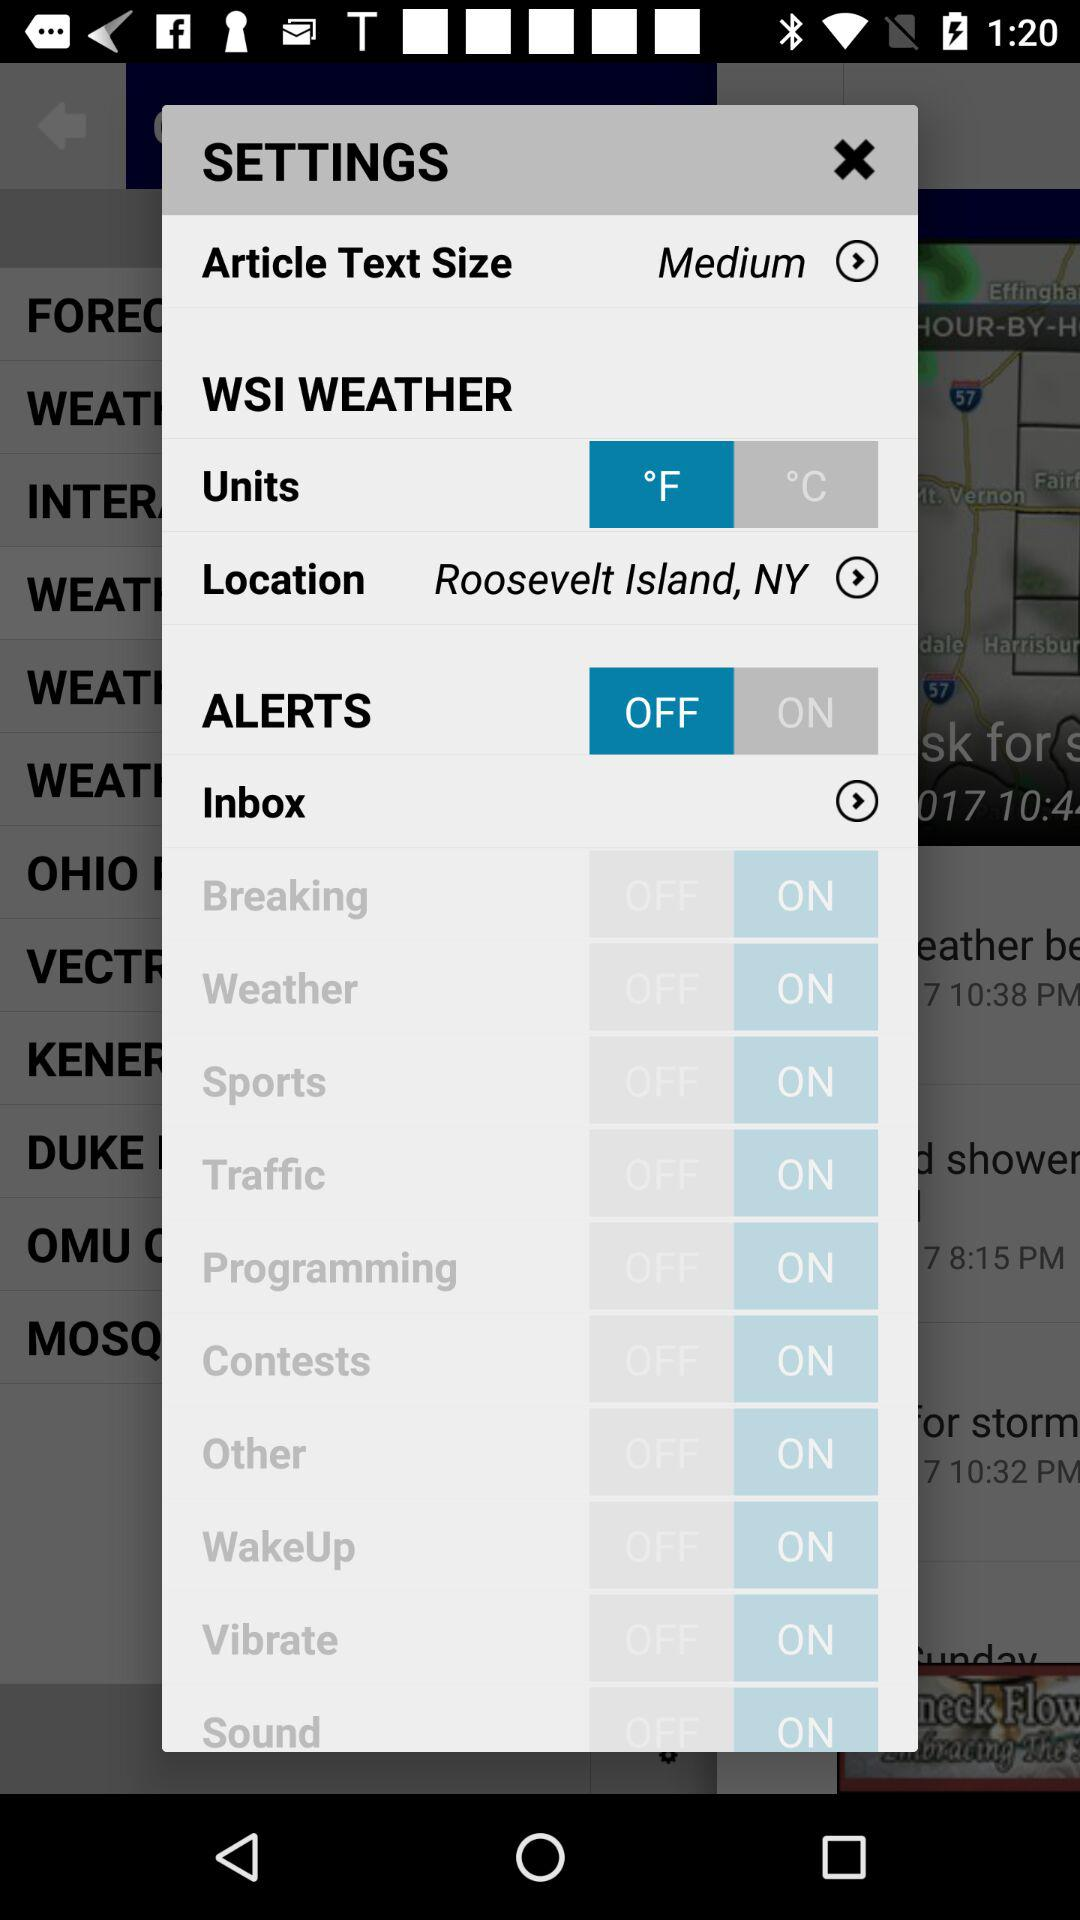What are the WSI weather units? The WSI weather units are °F and °C. 